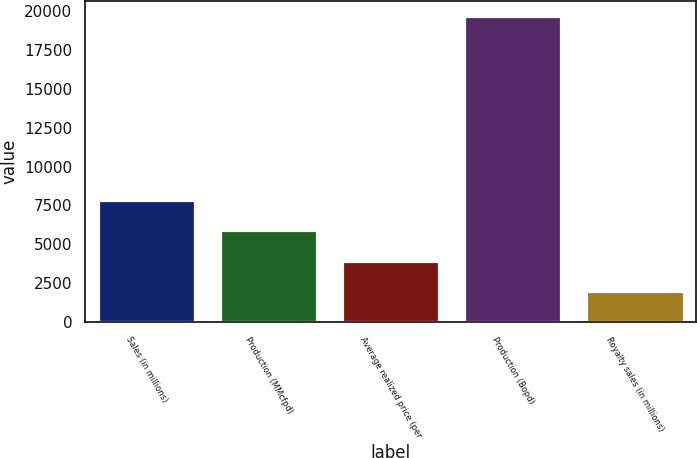Convert chart to OTSL. <chart><loc_0><loc_0><loc_500><loc_500><bar_chart><fcel>Sales (in millions)<fcel>Production (MMcfpd)<fcel>Average realized price (per<fcel>Production (Bopd)<fcel>Royalty sales (in millions)<nl><fcel>7862.45<fcel>5897.86<fcel>3933.27<fcel>19650<fcel>1968.68<nl></chart> 